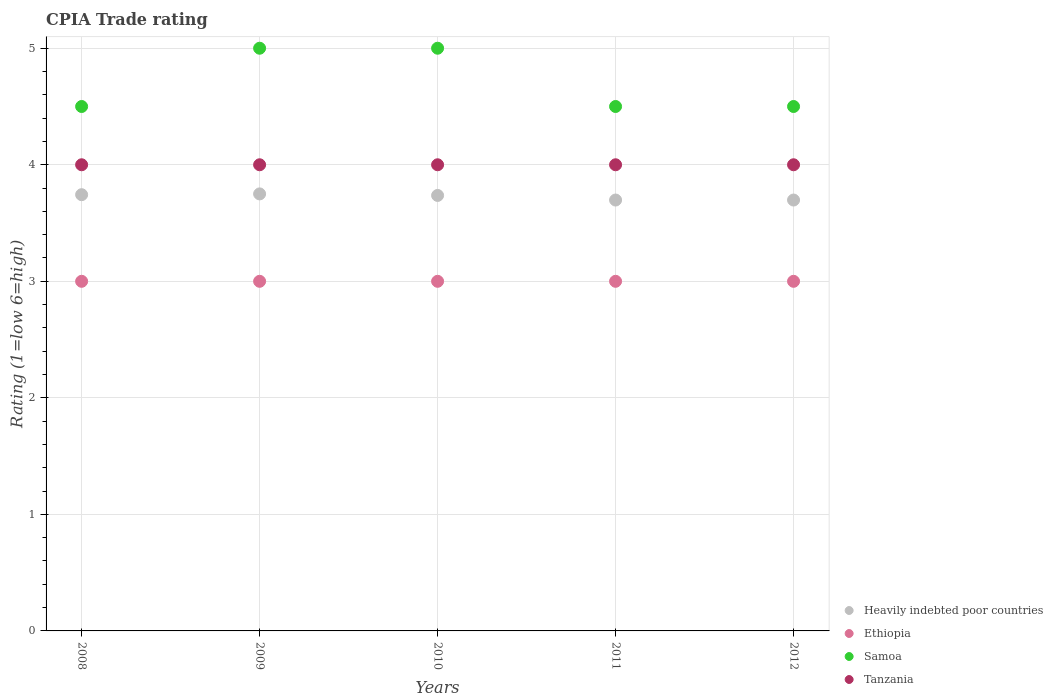What is the CPIA rating in Ethiopia in 2008?
Provide a succinct answer. 3. Across all years, what is the maximum CPIA rating in Ethiopia?
Offer a very short reply. 3. Across all years, what is the minimum CPIA rating in Ethiopia?
Offer a terse response. 3. In which year was the CPIA rating in Samoa maximum?
Your answer should be compact. 2009. What is the total CPIA rating in Heavily indebted poor countries in the graph?
Keep it short and to the point. 18.62. What is the difference between the CPIA rating in Ethiopia in 2008 and that in 2011?
Keep it short and to the point. 0. What is the average CPIA rating in Ethiopia per year?
Provide a succinct answer. 3. In the year 2010, what is the difference between the CPIA rating in Samoa and CPIA rating in Ethiopia?
Give a very brief answer. 2. In how many years, is the CPIA rating in Samoa greater than 0.4?
Keep it short and to the point. 5. Is the CPIA rating in Heavily indebted poor countries in 2008 less than that in 2010?
Your answer should be very brief. No. What is the difference between the highest and the second highest CPIA rating in Heavily indebted poor countries?
Your answer should be very brief. 0.01. In how many years, is the CPIA rating in Heavily indebted poor countries greater than the average CPIA rating in Heavily indebted poor countries taken over all years?
Your answer should be compact. 3. Is the sum of the CPIA rating in Tanzania in 2008 and 2012 greater than the maximum CPIA rating in Samoa across all years?
Provide a succinct answer. Yes. Is it the case that in every year, the sum of the CPIA rating in Heavily indebted poor countries and CPIA rating in Ethiopia  is greater than the sum of CPIA rating in Tanzania and CPIA rating in Samoa?
Offer a very short reply. Yes. Is the CPIA rating in Ethiopia strictly less than the CPIA rating in Heavily indebted poor countries over the years?
Provide a succinct answer. Yes. What is the difference between two consecutive major ticks on the Y-axis?
Offer a terse response. 1. Are the values on the major ticks of Y-axis written in scientific E-notation?
Offer a terse response. No. How are the legend labels stacked?
Give a very brief answer. Vertical. What is the title of the graph?
Ensure brevity in your answer.  CPIA Trade rating. Does "San Marino" appear as one of the legend labels in the graph?
Ensure brevity in your answer.  No. What is the label or title of the X-axis?
Provide a short and direct response. Years. What is the Rating (1=low 6=high) of Heavily indebted poor countries in 2008?
Make the answer very short. 3.74. What is the Rating (1=low 6=high) of Tanzania in 2008?
Ensure brevity in your answer.  4. What is the Rating (1=low 6=high) in Heavily indebted poor countries in 2009?
Your answer should be very brief. 3.75. What is the Rating (1=low 6=high) of Tanzania in 2009?
Your answer should be compact. 4. What is the Rating (1=low 6=high) in Heavily indebted poor countries in 2010?
Give a very brief answer. 3.74. What is the Rating (1=low 6=high) of Ethiopia in 2010?
Keep it short and to the point. 3. What is the Rating (1=low 6=high) in Samoa in 2010?
Offer a very short reply. 5. What is the Rating (1=low 6=high) of Heavily indebted poor countries in 2011?
Offer a very short reply. 3.7. What is the Rating (1=low 6=high) of Ethiopia in 2011?
Provide a short and direct response. 3. What is the Rating (1=low 6=high) in Heavily indebted poor countries in 2012?
Ensure brevity in your answer.  3.7. Across all years, what is the maximum Rating (1=low 6=high) of Heavily indebted poor countries?
Your answer should be very brief. 3.75. Across all years, what is the maximum Rating (1=low 6=high) of Ethiopia?
Offer a very short reply. 3. Across all years, what is the minimum Rating (1=low 6=high) of Heavily indebted poor countries?
Provide a succinct answer. 3.7. Across all years, what is the minimum Rating (1=low 6=high) of Samoa?
Offer a very short reply. 4.5. What is the total Rating (1=low 6=high) of Heavily indebted poor countries in the graph?
Your answer should be compact. 18.62. What is the total Rating (1=low 6=high) in Ethiopia in the graph?
Offer a terse response. 15. What is the total Rating (1=low 6=high) of Samoa in the graph?
Offer a terse response. 23.5. What is the difference between the Rating (1=low 6=high) of Heavily indebted poor countries in 2008 and that in 2009?
Give a very brief answer. -0.01. What is the difference between the Rating (1=low 6=high) in Tanzania in 2008 and that in 2009?
Offer a very short reply. 0. What is the difference between the Rating (1=low 6=high) of Heavily indebted poor countries in 2008 and that in 2010?
Offer a terse response. 0.01. What is the difference between the Rating (1=low 6=high) of Samoa in 2008 and that in 2010?
Your response must be concise. -0.5. What is the difference between the Rating (1=low 6=high) in Tanzania in 2008 and that in 2010?
Offer a terse response. 0. What is the difference between the Rating (1=low 6=high) of Heavily indebted poor countries in 2008 and that in 2011?
Offer a very short reply. 0.05. What is the difference between the Rating (1=low 6=high) in Ethiopia in 2008 and that in 2011?
Give a very brief answer. 0. What is the difference between the Rating (1=low 6=high) in Tanzania in 2008 and that in 2011?
Your answer should be compact. 0. What is the difference between the Rating (1=low 6=high) in Heavily indebted poor countries in 2008 and that in 2012?
Ensure brevity in your answer.  0.05. What is the difference between the Rating (1=low 6=high) of Ethiopia in 2008 and that in 2012?
Your response must be concise. 0. What is the difference between the Rating (1=low 6=high) of Samoa in 2008 and that in 2012?
Keep it short and to the point. 0. What is the difference between the Rating (1=low 6=high) of Heavily indebted poor countries in 2009 and that in 2010?
Keep it short and to the point. 0.01. What is the difference between the Rating (1=low 6=high) of Ethiopia in 2009 and that in 2010?
Your answer should be very brief. 0. What is the difference between the Rating (1=low 6=high) in Heavily indebted poor countries in 2009 and that in 2011?
Offer a terse response. 0.05. What is the difference between the Rating (1=low 6=high) in Ethiopia in 2009 and that in 2011?
Ensure brevity in your answer.  0. What is the difference between the Rating (1=low 6=high) of Heavily indebted poor countries in 2009 and that in 2012?
Offer a very short reply. 0.05. What is the difference between the Rating (1=low 6=high) in Tanzania in 2009 and that in 2012?
Make the answer very short. 0. What is the difference between the Rating (1=low 6=high) of Heavily indebted poor countries in 2010 and that in 2011?
Your answer should be compact. 0.04. What is the difference between the Rating (1=low 6=high) of Tanzania in 2010 and that in 2011?
Offer a terse response. 0. What is the difference between the Rating (1=low 6=high) in Heavily indebted poor countries in 2010 and that in 2012?
Ensure brevity in your answer.  0.04. What is the difference between the Rating (1=low 6=high) in Samoa in 2010 and that in 2012?
Keep it short and to the point. 0.5. What is the difference between the Rating (1=low 6=high) of Heavily indebted poor countries in 2011 and that in 2012?
Ensure brevity in your answer.  0. What is the difference between the Rating (1=low 6=high) in Samoa in 2011 and that in 2012?
Provide a short and direct response. 0. What is the difference between the Rating (1=low 6=high) in Heavily indebted poor countries in 2008 and the Rating (1=low 6=high) in Ethiopia in 2009?
Offer a terse response. 0.74. What is the difference between the Rating (1=low 6=high) of Heavily indebted poor countries in 2008 and the Rating (1=low 6=high) of Samoa in 2009?
Offer a very short reply. -1.26. What is the difference between the Rating (1=low 6=high) of Heavily indebted poor countries in 2008 and the Rating (1=low 6=high) of Tanzania in 2009?
Make the answer very short. -0.26. What is the difference between the Rating (1=low 6=high) of Ethiopia in 2008 and the Rating (1=low 6=high) of Samoa in 2009?
Your response must be concise. -2. What is the difference between the Rating (1=low 6=high) in Samoa in 2008 and the Rating (1=low 6=high) in Tanzania in 2009?
Ensure brevity in your answer.  0.5. What is the difference between the Rating (1=low 6=high) in Heavily indebted poor countries in 2008 and the Rating (1=low 6=high) in Ethiopia in 2010?
Offer a very short reply. 0.74. What is the difference between the Rating (1=low 6=high) in Heavily indebted poor countries in 2008 and the Rating (1=low 6=high) in Samoa in 2010?
Keep it short and to the point. -1.26. What is the difference between the Rating (1=low 6=high) in Heavily indebted poor countries in 2008 and the Rating (1=low 6=high) in Tanzania in 2010?
Your answer should be compact. -0.26. What is the difference between the Rating (1=low 6=high) of Heavily indebted poor countries in 2008 and the Rating (1=low 6=high) of Ethiopia in 2011?
Your response must be concise. 0.74. What is the difference between the Rating (1=low 6=high) in Heavily indebted poor countries in 2008 and the Rating (1=low 6=high) in Samoa in 2011?
Offer a very short reply. -0.76. What is the difference between the Rating (1=low 6=high) in Heavily indebted poor countries in 2008 and the Rating (1=low 6=high) in Tanzania in 2011?
Give a very brief answer. -0.26. What is the difference between the Rating (1=low 6=high) in Ethiopia in 2008 and the Rating (1=low 6=high) in Samoa in 2011?
Provide a short and direct response. -1.5. What is the difference between the Rating (1=low 6=high) of Ethiopia in 2008 and the Rating (1=low 6=high) of Tanzania in 2011?
Your answer should be compact. -1. What is the difference between the Rating (1=low 6=high) of Heavily indebted poor countries in 2008 and the Rating (1=low 6=high) of Ethiopia in 2012?
Provide a succinct answer. 0.74. What is the difference between the Rating (1=low 6=high) in Heavily indebted poor countries in 2008 and the Rating (1=low 6=high) in Samoa in 2012?
Make the answer very short. -0.76. What is the difference between the Rating (1=low 6=high) in Heavily indebted poor countries in 2008 and the Rating (1=low 6=high) in Tanzania in 2012?
Ensure brevity in your answer.  -0.26. What is the difference between the Rating (1=low 6=high) of Ethiopia in 2008 and the Rating (1=low 6=high) of Tanzania in 2012?
Your response must be concise. -1. What is the difference between the Rating (1=low 6=high) of Samoa in 2008 and the Rating (1=low 6=high) of Tanzania in 2012?
Your answer should be very brief. 0.5. What is the difference between the Rating (1=low 6=high) in Heavily indebted poor countries in 2009 and the Rating (1=low 6=high) in Samoa in 2010?
Your answer should be very brief. -1.25. What is the difference between the Rating (1=low 6=high) of Heavily indebted poor countries in 2009 and the Rating (1=low 6=high) of Tanzania in 2010?
Provide a succinct answer. -0.25. What is the difference between the Rating (1=low 6=high) in Ethiopia in 2009 and the Rating (1=low 6=high) in Tanzania in 2010?
Provide a short and direct response. -1. What is the difference between the Rating (1=low 6=high) in Heavily indebted poor countries in 2009 and the Rating (1=low 6=high) in Samoa in 2011?
Keep it short and to the point. -0.75. What is the difference between the Rating (1=low 6=high) of Heavily indebted poor countries in 2009 and the Rating (1=low 6=high) of Tanzania in 2011?
Ensure brevity in your answer.  -0.25. What is the difference between the Rating (1=low 6=high) of Samoa in 2009 and the Rating (1=low 6=high) of Tanzania in 2011?
Your response must be concise. 1. What is the difference between the Rating (1=low 6=high) in Heavily indebted poor countries in 2009 and the Rating (1=low 6=high) in Samoa in 2012?
Your response must be concise. -0.75. What is the difference between the Rating (1=low 6=high) of Heavily indebted poor countries in 2009 and the Rating (1=low 6=high) of Tanzania in 2012?
Offer a very short reply. -0.25. What is the difference between the Rating (1=low 6=high) in Ethiopia in 2009 and the Rating (1=low 6=high) in Tanzania in 2012?
Provide a short and direct response. -1. What is the difference between the Rating (1=low 6=high) of Heavily indebted poor countries in 2010 and the Rating (1=low 6=high) of Ethiopia in 2011?
Make the answer very short. 0.74. What is the difference between the Rating (1=low 6=high) in Heavily indebted poor countries in 2010 and the Rating (1=low 6=high) in Samoa in 2011?
Ensure brevity in your answer.  -0.76. What is the difference between the Rating (1=low 6=high) in Heavily indebted poor countries in 2010 and the Rating (1=low 6=high) in Tanzania in 2011?
Offer a very short reply. -0.26. What is the difference between the Rating (1=low 6=high) of Ethiopia in 2010 and the Rating (1=low 6=high) of Samoa in 2011?
Offer a very short reply. -1.5. What is the difference between the Rating (1=low 6=high) in Ethiopia in 2010 and the Rating (1=low 6=high) in Tanzania in 2011?
Provide a short and direct response. -1. What is the difference between the Rating (1=low 6=high) of Samoa in 2010 and the Rating (1=low 6=high) of Tanzania in 2011?
Give a very brief answer. 1. What is the difference between the Rating (1=low 6=high) in Heavily indebted poor countries in 2010 and the Rating (1=low 6=high) in Ethiopia in 2012?
Offer a very short reply. 0.74. What is the difference between the Rating (1=low 6=high) in Heavily indebted poor countries in 2010 and the Rating (1=low 6=high) in Samoa in 2012?
Make the answer very short. -0.76. What is the difference between the Rating (1=low 6=high) in Heavily indebted poor countries in 2010 and the Rating (1=low 6=high) in Tanzania in 2012?
Provide a succinct answer. -0.26. What is the difference between the Rating (1=low 6=high) of Ethiopia in 2010 and the Rating (1=low 6=high) of Samoa in 2012?
Offer a terse response. -1.5. What is the difference between the Rating (1=low 6=high) in Heavily indebted poor countries in 2011 and the Rating (1=low 6=high) in Ethiopia in 2012?
Provide a short and direct response. 0.7. What is the difference between the Rating (1=low 6=high) of Heavily indebted poor countries in 2011 and the Rating (1=low 6=high) of Samoa in 2012?
Your response must be concise. -0.8. What is the difference between the Rating (1=low 6=high) of Heavily indebted poor countries in 2011 and the Rating (1=low 6=high) of Tanzania in 2012?
Your response must be concise. -0.3. What is the difference between the Rating (1=low 6=high) of Ethiopia in 2011 and the Rating (1=low 6=high) of Samoa in 2012?
Give a very brief answer. -1.5. What is the difference between the Rating (1=low 6=high) in Ethiopia in 2011 and the Rating (1=low 6=high) in Tanzania in 2012?
Your answer should be compact. -1. What is the average Rating (1=low 6=high) in Heavily indebted poor countries per year?
Keep it short and to the point. 3.73. What is the average Rating (1=low 6=high) of Samoa per year?
Your answer should be compact. 4.7. What is the average Rating (1=low 6=high) in Tanzania per year?
Make the answer very short. 4. In the year 2008, what is the difference between the Rating (1=low 6=high) of Heavily indebted poor countries and Rating (1=low 6=high) of Ethiopia?
Give a very brief answer. 0.74. In the year 2008, what is the difference between the Rating (1=low 6=high) in Heavily indebted poor countries and Rating (1=low 6=high) in Samoa?
Make the answer very short. -0.76. In the year 2008, what is the difference between the Rating (1=low 6=high) in Heavily indebted poor countries and Rating (1=low 6=high) in Tanzania?
Make the answer very short. -0.26. In the year 2008, what is the difference between the Rating (1=low 6=high) of Ethiopia and Rating (1=low 6=high) of Tanzania?
Provide a succinct answer. -1. In the year 2009, what is the difference between the Rating (1=low 6=high) of Heavily indebted poor countries and Rating (1=low 6=high) of Samoa?
Keep it short and to the point. -1.25. In the year 2009, what is the difference between the Rating (1=low 6=high) of Heavily indebted poor countries and Rating (1=low 6=high) of Tanzania?
Offer a very short reply. -0.25. In the year 2009, what is the difference between the Rating (1=low 6=high) of Ethiopia and Rating (1=low 6=high) of Tanzania?
Keep it short and to the point. -1. In the year 2010, what is the difference between the Rating (1=low 6=high) of Heavily indebted poor countries and Rating (1=low 6=high) of Ethiopia?
Your response must be concise. 0.74. In the year 2010, what is the difference between the Rating (1=low 6=high) of Heavily indebted poor countries and Rating (1=low 6=high) of Samoa?
Provide a short and direct response. -1.26. In the year 2010, what is the difference between the Rating (1=low 6=high) in Heavily indebted poor countries and Rating (1=low 6=high) in Tanzania?
Your response must be concise. -0.26. In the year 2010, what is the difference between the Rating (1=low 6=high) in Ethiopia and Rating (1=low 6=high) in Samoa?
Your answer should be compact. -2. In the year 2011, what is the difference between the Rating (1=low 6=high) in Heavily indebted poor countries and Rating (1=low 6=high) in Ethiopia?
Offer a terse response. 0.7. In the year 2011, what is the difference between the Rating (1=low 6=high) of Heavily indebted poor countries and Rating (1=low 6=high) of Samoa?
Give a very brief answer. -0.8. In the year 2011, what is the difference between the Rating (1=low 6=high) of Heavily indebted poor countries and Rating (1=low 6=high) of Tanzania?
Make the answer very short. -0.3. In the year 2011, what is the difference between the Rating (1=low 6=high) of Ethiopia and Rating (1=low 6=high) of Tanzania?
Offer a very short reply. -1. In the year 2011, what is the difference between the Rating (1=low 6=high) of Samoa and Rating (1=low 6=high) of Tanzania?
Provide a short and direct response. 0.5. In the year 2012, what is the difference between the Rating (1=low 6=high) of Heavily indebted poor countries and Rating (1=low 6=high) of Ethiopia?
Your answer should be compact. 0.7. In the year 2012, what is the difference between the Rating (1=low 6=high) in Heavily indebted poor countries and Rating (1=low 6=high) in Samoa?
Keep it short and to the point. -0.8. In the year 2012, what is the difference between the Rating (1=low 6=high) in Heavily indebted poor countries and Rating (1=low 6=high) in Tanzania?
Your answer should be compact. -0.3. In the year 2012, what is the difference between the Rating (1=low 6=high) of Samoa and Rating (1=low 6=high) of Tanzania?
Provide a succinct answer. 0.5. What is the ratio of the Rating (1=low 6=high) of Heavily indebted poor countries in 2008 to that in 2009?
Your answer should be compact. 1. What is the ratio of the Rating (1=low 6=high) in Ethiopia in 2008 to that in 2009?
Give a very brief answer. 1. What is the ratio of the Rating (1=low 6=high) in Samoa in 2008 to that in 2009?
Ensure brevity in your answer.  0.9. What is the ratio of the Rating (1=low 6=high) of Heavily indebted poor countries in 2008 to that in 2010?
Your answer should be very brief. 1. What is the ratio of the Rating (1=low 6=high) of Tanzania in 2008 to that in 2010?
Provide a succinct answer. 1. What is the ratio of the Rating (1=low 6=high) in Heavily indebted poor countries in 2008 to that in 2011?
Offer a terse response. 1.01. What is the ratio of the Rating (1=low 6=high) of Ethiopia in 2008 to that in 2011?
Your answer should be very brief. 1. What is the ratio of the Rating (1=low 6=high) of Samoa in 2008 to that in 2011?
Your answer should be very brief. 1. What is the ratio of the Rating (1=low 6=high) of Heavily indebted poor countries in 2008 to that in 2012?
Your answer should be very brief. 1.01. What is the ratio of the Rating (1=low 6=high) in Samoa in 2008 to that in 2012?
Offer a terse response. 1. What is the ratio of the Rating (1=low 6=high) of Tanzania in 2008 to that in 2012?
Offer a very short reply. 1. What is the ratio of the Rating (1=low 6=high) in Ethiopia in 2009 to that in 2010?
Offer a very short reply. 1. What is the ratio of the Rating (1=low 6=high) of Samoa in 2009 to that in 2010?
Your answer should be very brief. 1. What is the ratio of the Rating (1=low 6=high) in Tanzania in 2009 to that in 2010?
Your answer should be compact. 1. What is the ratio of the Rating (1=low 6=high) of Heavily indebted poor countries in 2009 to that in 2011?
Provide a short and direct response. 1.01. What is the ratio of the Rating (1=low 6=high) in Tanzania in 2009 to that in 2011?
Keep it short and to the point. 1. What is the ratio of the Rating (1=low 6=high) of Heavily indebted poor countries in 2009 to that in 2012?
Ensure brevity in your answer.  1.01. What is the ratio of the Rating (1=low 6=high) in Tanzania in 2009 to that in 2012?
Make the answer very short. 1. What is the ratio of the Rating (1=low 6=high) of Heavily indebted poor countries in 2010 to that in 2011?
Offer a terse response. 1.01. What is the ratio of the Rating (1=low 6=high) of Samoa in 2010 to that in 2011?
Your answer should be very brief. 1.11. What is the ratio of the Rating (1=low 6=high) in Heavily indebted poor countries in 2010 to that in 2012?
Your response must be concise. 1.01. What is the ratio of the Rating (1=low 6=high) in Ethiopia in 2010 to that in 2012?
Offer a very short reply. 1. What is the ratio of the Rating (1=low 6=high) in Samoa in 2010 to that in 2012?
Keep it short and to the point. 1.11. What is the ratio of the Rating (1=low 6=high) of Ethiopia in 2011 to that in 2012?
Ensure brevity in your answer.  1. What is the difference between the highest and the second highest Rating (1=low 6=high) of Heavily indebted poor countries?
Give a very brief answer. 0.01. What is the difference between the highest and the second highest Rating (1=low 6=high) in Tanzania?
Provide a succinct answer. 0. What is the difference between the highest and the lowest Rating (1=low 6=high) in Heavily indebted poor countries?
Provide a short and direct response. 0.05. What is the difference between the highest and the lowest Rating (1=low 6=high) of Ethiopia?
Give a very brief answer. 0. What is the difference between the highest and the lowest Rating (1=low 6=high) of Samoa?
Offer a very short reply. 0.5. 